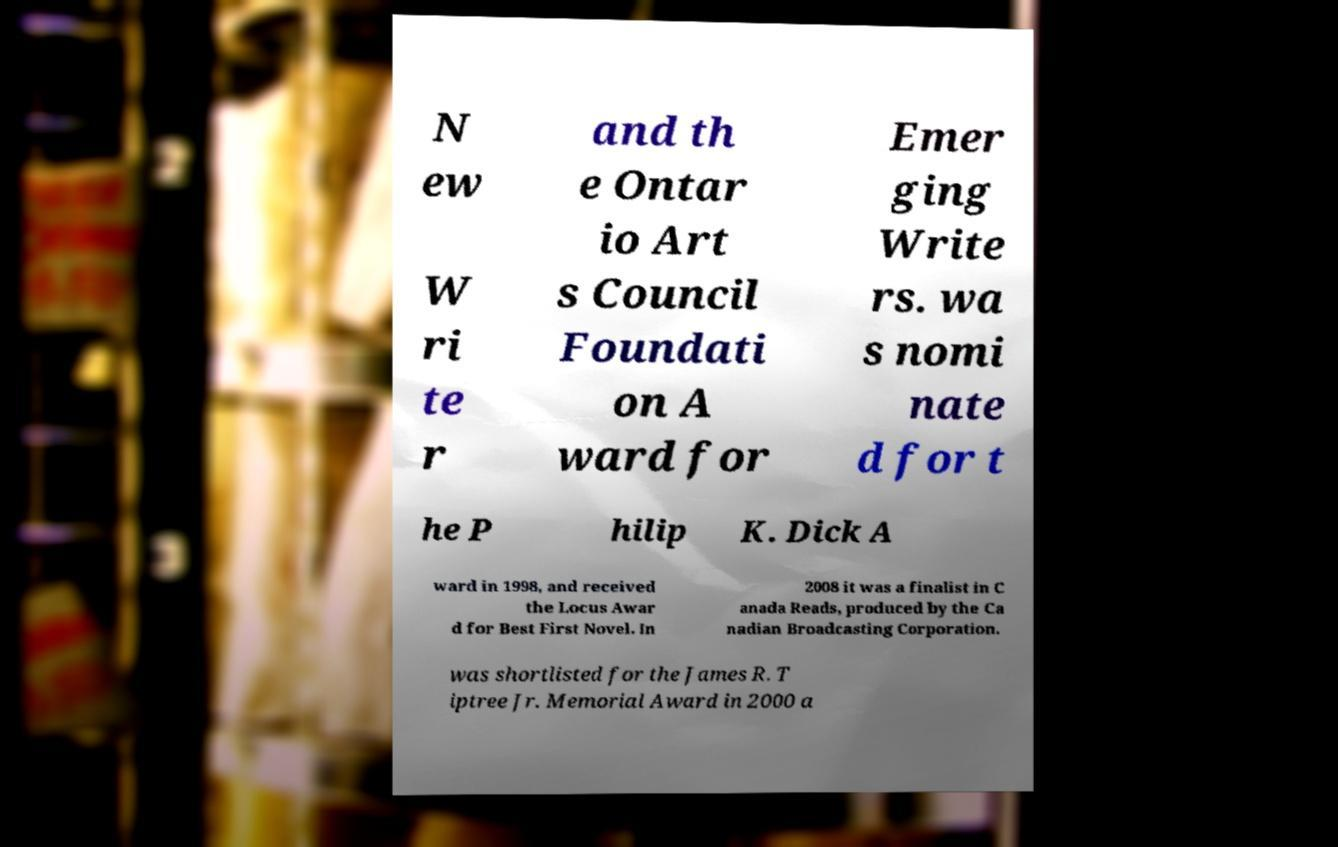Please identify and transcribe the text found in this image. N ew W ri te r and th e Ontar io Art s Council Foundati on A ward for Emer ging Write rs. wa s nomi nate d for t he P hilip K. Dick A ward in 1998, and received the Locus Awar d for Best First Novel. In 2008 it was a finalist in C anada Reads, produced by the Ca nadian Broadcasting Corporation. was shortlisted for the James R. T iptree Jr. Memorial Award in 2000 a 